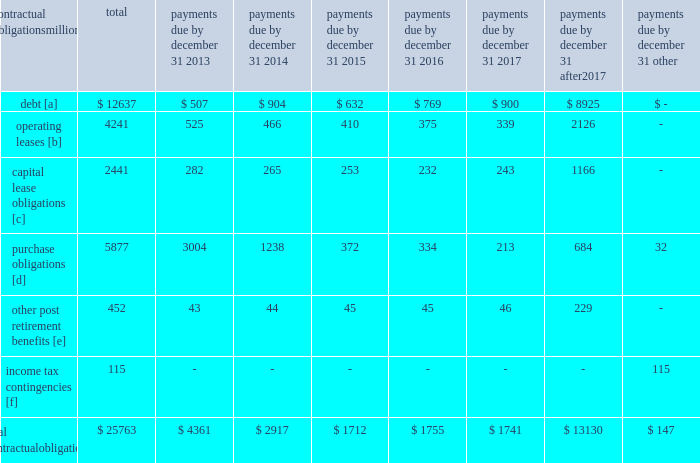Credit rating fall below investment grade , the value of the outstanding undivided interest held by investors would be reduced , and , in certain cases , the investors would have the right to discontinue the facility .
The railroad collected approximately $ 20.1 billion and $ 18.8 billion of receivables during the years ended december 31 , 2012 and 2011 , respectively .
Upri used certain of these proceeds to purchase new receivables under the facility .
The costs of the receivables securitization facility include interest , which will vary based on prevailing commercial paper rates , program fees paid to banks , commercial paper issuing costs , and fees for unused commitment availability .
The costs of the receivables securitization facility are included in interest expense and were $ 3 million , $ 4 million and $ 6 million for 2012 , 2011 and 2010 , respectively .
The investors have no recourse to the railroad 2019s other assets , except for customary warranty and indemnity claims .
Creditors of the railroad do not have recourse to the assets of upri .
In july 2012 , the receivables securitization facility was renewed for an additional 364-day period at comparable terms and conditions .
Subsequent event 2013 on january 2 , 2013 , we transferred an additional $ 300 million in undivided interest to investors under the receivables securitization facility , increasing the value of the outstanding undivided interest held by investors from $ 100 million to $ 400 million .
Contractual obligations and commercial commitments as described in the notes to the consolidated financial statements and as referenced in the tables below , we have contractual obligations and commercial commitments that may affect our financial condition .
Based on our assessment of the underlying provisions and circumstances of our contractual obligations and commercial commitments , including material sources of off-balance sheet and structured finance arrangements , other than the risks that we and other similarly situated companies face with respect to the condition of the capital markets ( as described in item 1a of part ii of this report ) , there is no known trend , demand , commitment , event , or uncertainty that is reasonably likely to occur that would have a material adverse effect on our consolidated results of operations , financial condition , or liquidity .
In addition , our commercial obligations , financings , and commitments are customary transactions that are similar to those of other comparable corporations , particularly within the transportation industry .
The tables identify material obligations and commitments as of december 31 , 2012 : payments due by december 31 , contractual obligations after millions total 2013 2014 2015 2016 2017 2017 other .
[a] excludes capital lease obligations of $ 1848 million and unamortized discount of $ ( 365 ) million .
Includes an interest component of $ 5123 million .
[b] includes leases for locomotives , freight cars , other equipment , and real estate .
[c] represents total obligations , including interest component of $ 593 million .
[d] purchase obligations include locomotive maintenance contracts ; purchase commitments for fuel purchases , locomotives , ties , ballast , and rail ; and agreements to purchase other goods and services .
For amounts where we cannot reasonably estimate the year of settlement , they are reflected in the other column .
[e] includes estimated other post retirement , medical , and life insurance payments , payments made under the unfunded pension plan for the next ten years .
[f] future cash flows for income tax contingencies reflect the recorded liabilities and assets for unrecognized tax benefits , including interest and penalties , as of december 31 , 2012 .
For amounts where the year of settlement is uncertain , they are reflected in the other column. .
What is the principal portion of total capital lease obligations , in millions? 
Rationale: total less interest portion
Computations: (2441 - 593)
Answer: 1848.0. 